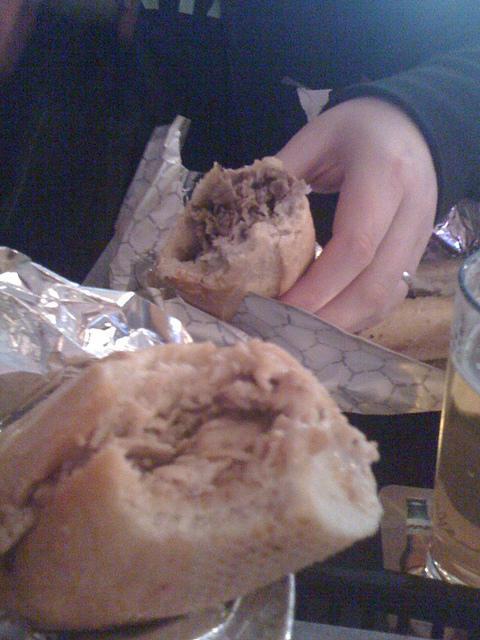How many sandwiches do you see?
Give a very brief answer. 2. How many sandwiches can be seen?
Give a very brief answer. 2. 